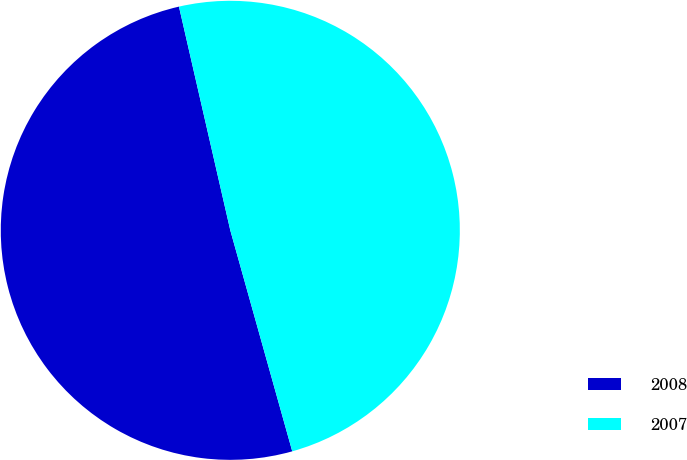<chart> <loc_0><loc_0><loc_500><loc_500><pie_chart><fcel>2008<fcel>2007<nl><fcel>50.76%<fcel>49.24%<nl></chart> 